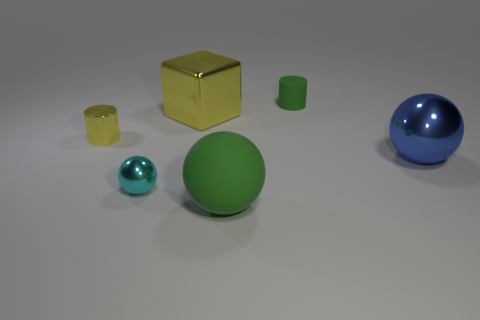Does the material of the objects affect how light interacts with their surfaces? Absolutely, the objects exhibit different finishes; the spheres and the cylinder have a more reflective surface that catches the light, whereas the cubes have a matte finish diffusing the light, making their appearances quite distinct.  What can you tell about the texture of these objects? From the image, we can observe that the objects appear to have smooth surfaces, which is indicative of a polished texture, especially noticeable on the reflective surfaces of the spheres and cylinder. 